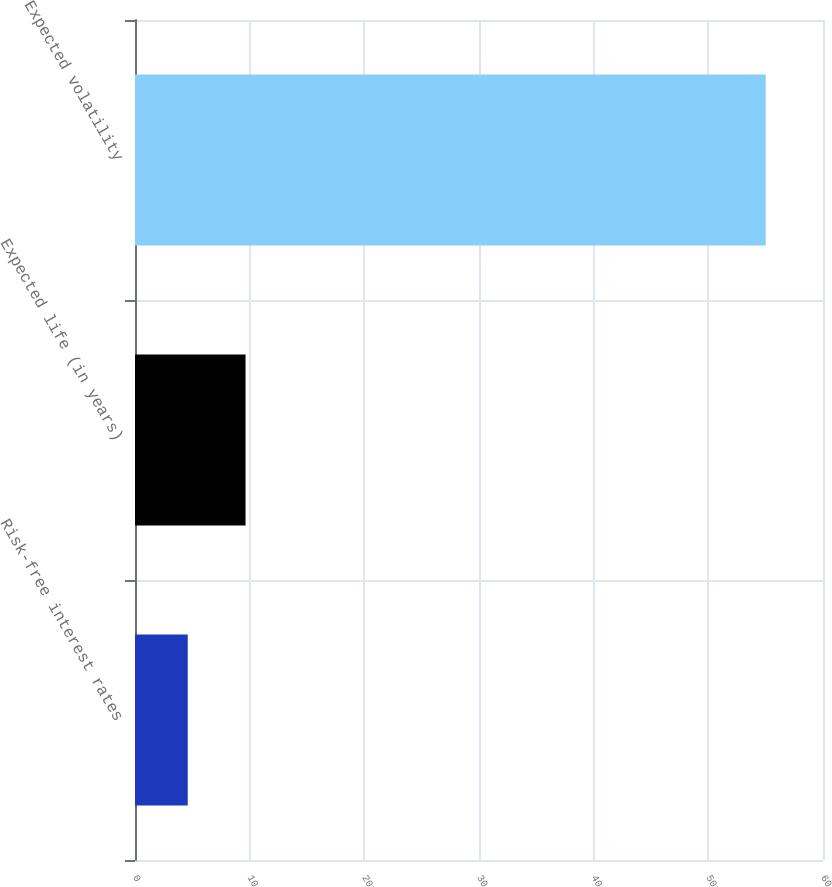Convert chart to OTSL. <chart><loc_0><loc_0><loc_500><loc_500><bar_chart><fcel>Risk-free interest rates<fcel>Expected life (in years)<fcel>Expected volatility<nl><fcel>4.6<fcel>9.64<fcel>55<nl></chart> 